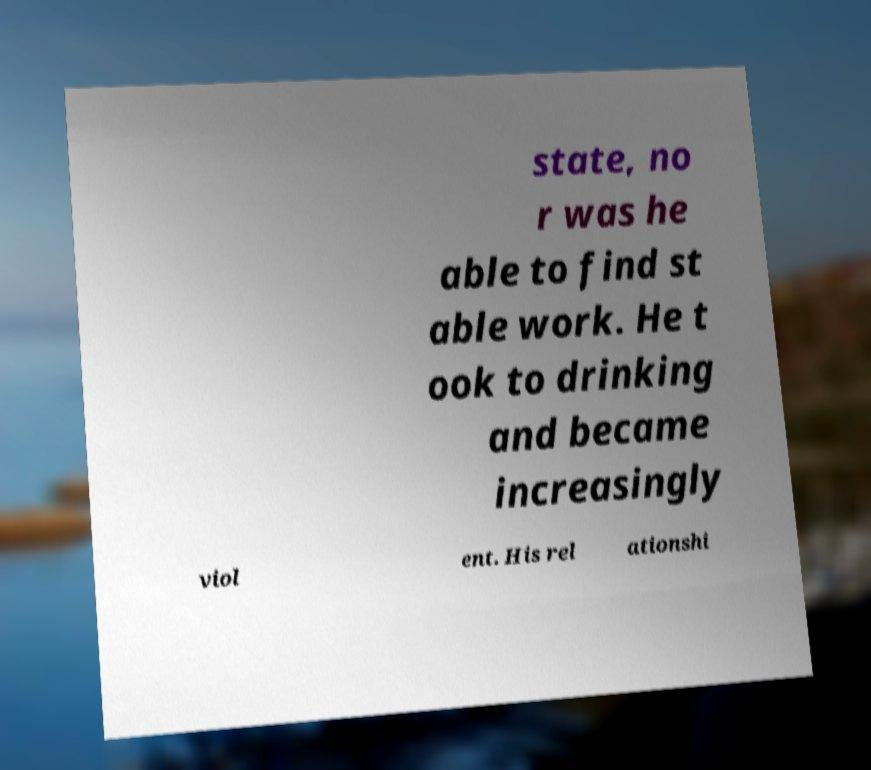Can you accurately transcribe the text from the provided image for me? state, no r was he able to find st able work. He t ook to drinking and became increasingly viol ent. His rel ationshi 